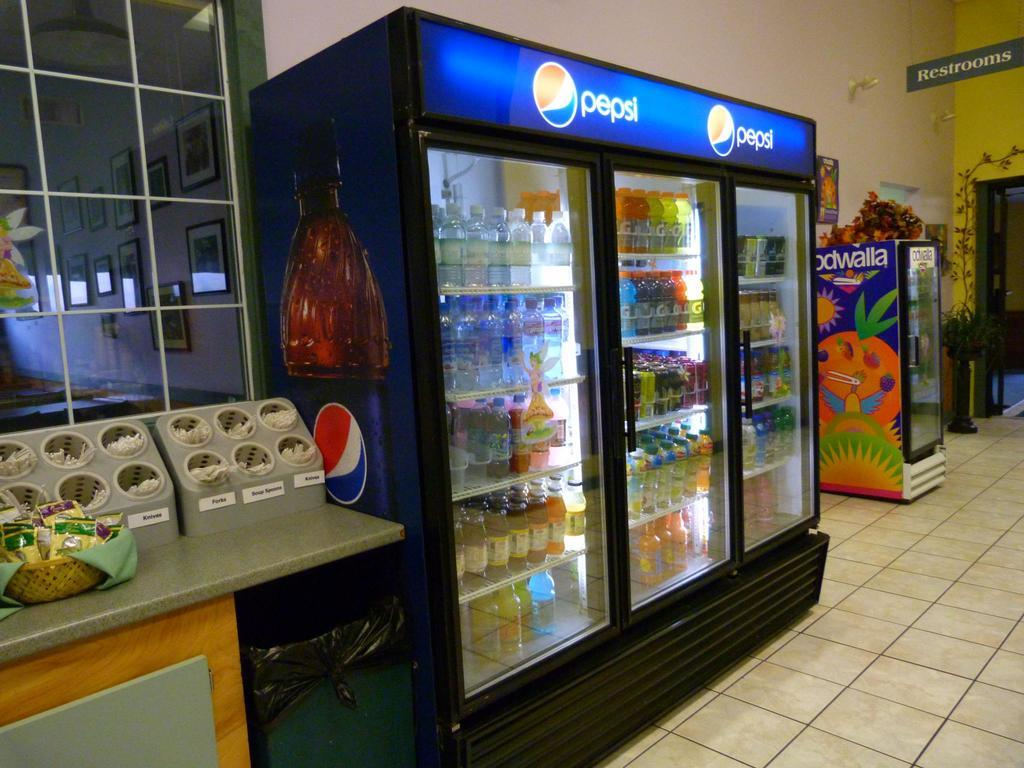<image>
Describe the image concisely. Knives, forks and spoons can be found next to the Pepsi refrigerator. 